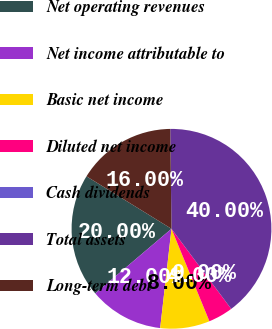Convert chart. <chart><loc_0><loc_0><loc_500><loc_500><pie_chart><fcel>Net operating revenues<fcel>Net income attributable to<fcel>Basic net income<fcel>Diluted net income<fcel>Cash dividends<fcel>Total assets<fcel>Long-term debt<nl><fcel>20.0%<fcel>12.0%<fcel>8.0%<fcel>4.0%<fcel>0.0%<fcel>40.0%<fcel>16.0%<nl></chart> 